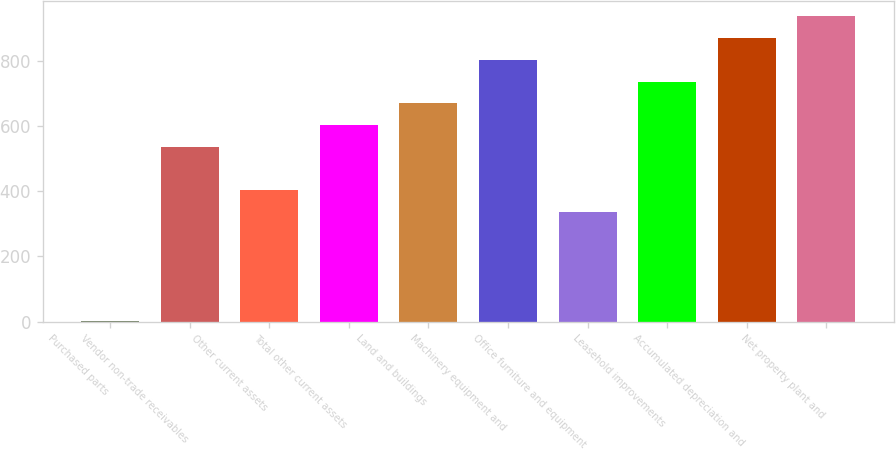Convert chart. <chart><loc_0><loc_0><loc_500><loc_500><bar_chart><fcel>Purchased parts<fcel>Vendor non-trade receivables<fcel>Other current assets<fcel>Total other current assets<fcel>Land and buildings<fcel>Machinery equipment and<fcel>Office furniture and equipment<fcel>Leasehold improvements<fcel>Accumulated depreciation and<fcel>Net property plant and<nl><fcel>2<fcel>535.6<fcel>402.2<fcel>602.3<fcel>669<fcel>802.4<fcel>335.5<fcel>735.7<fcel>869.1<fcel>935.8<nl></chart> 